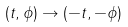Convert formula to latex. <formula><loc_0><loc_0><loc_500><loc_500>( t , \phi ) \to ( - t , - \phi )</formula> 